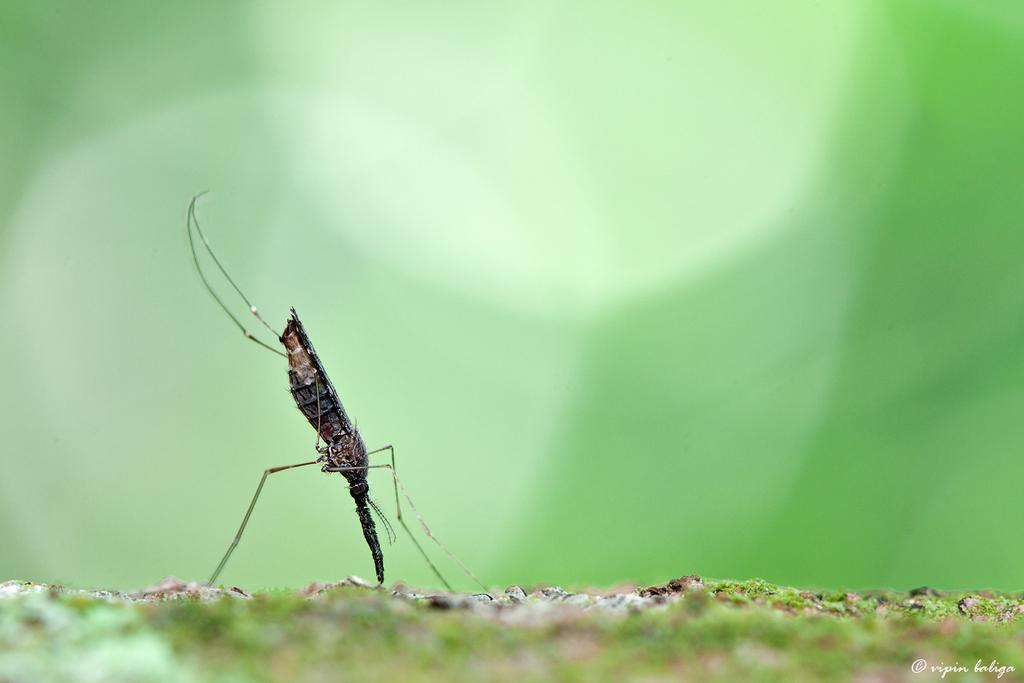What is the main subject in the center of the image? There is an insect in the center of the image. Is there any additional information or markings on the image? Yes, there is a watermark on the right bottom of the image. How does the river contribute to the trouble in the image? There is no river present in the image, so it cannot contribute to any trouble. 